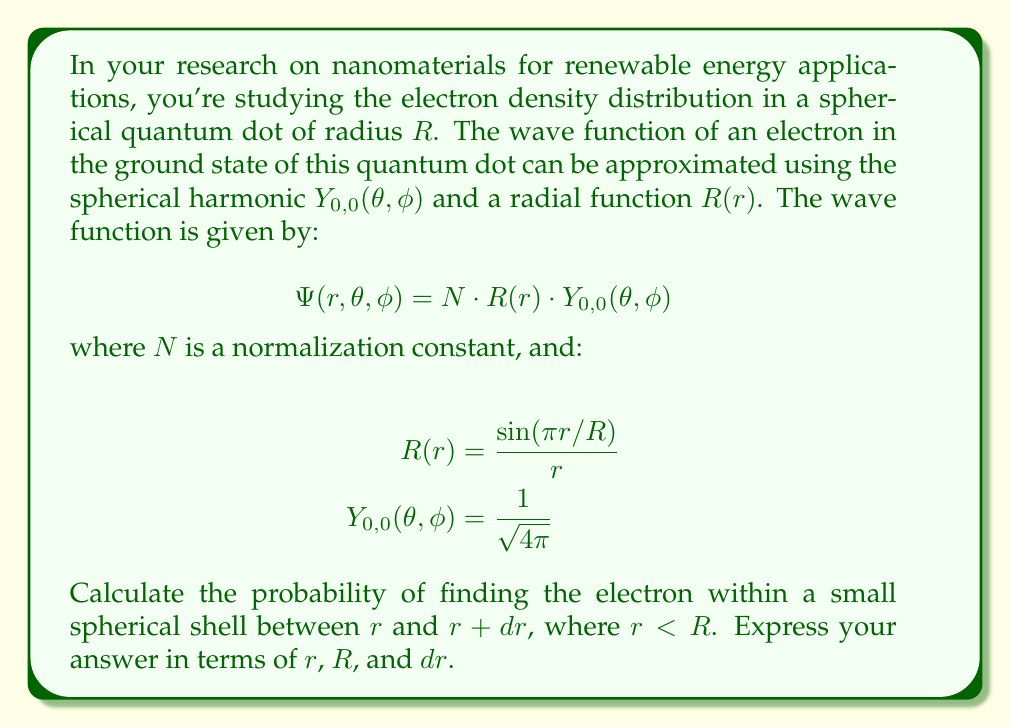Teach me how to tackle this problem. To solve this problem, we'll follow these steps:

1) First, recall that the probability density is given by the square of the wave function's magnitude:
   $$|\Psi(r,\theta,\phi)|^2 = |N|^2 \cdot |R(r)|^2 \cdot |Y_{0,0}(\theta,\phi)|^2$$

2) We're interested in the radial probability, so we need to integrate over the angular variables $\theta$ and $\phi$. The spherical harmonic $Y_{0,0}(\theta,\phi)$ is already normalized, so:
   $$\int_0^{2\pi} \int_0^{\pi} |Y_{0,0}(\theta,\phi)|^2 \sin\theta d\theta d\phi = 1$$

3) The probability of finding the electron in a spherical shell between $r$ and $r+dr$ is:
   $$P(r)dr = 4\pi r^2 |N|^2 |R(r)|^2 dr$$

4) Now, let's substitute the expression for $R(r)$:
   $$P(r)dr = 4\pi r^2 |N|^2 \left|\frac{\sin(\pi r/R)}{r}\right|^2 dr$$

5) Simplify:
   $$P(r)dr = 4\pi |N|^2 \frac{\sin^2(\pi r/R)}{r^2} r^2 dr = 4\pi |N|^2 \sin^2(\pi r/R) dr$$

6) The normalization constant $N$ ensures that the total probability over all space is 1:
   $$\int_0^R P(r)dr = 1$$
   
   However, we don't need to calculate $N$ explicitly for this problem.

Therefore, the probability of finding the electron within a small spherical shell between $r$ and $r+dr$ is proportional to $\sin^2(\pi r/R)$.
Answer: The probability of finding the electron within a small spherical shell between $r$ and $r+dr$ is:

$$P(r)dr = C \sin^2(\pi r/R) dr$$

where $C$ is a constant that depends on the normalization factor $N$. This expression is valid for $0 \leq r \leq R$. 